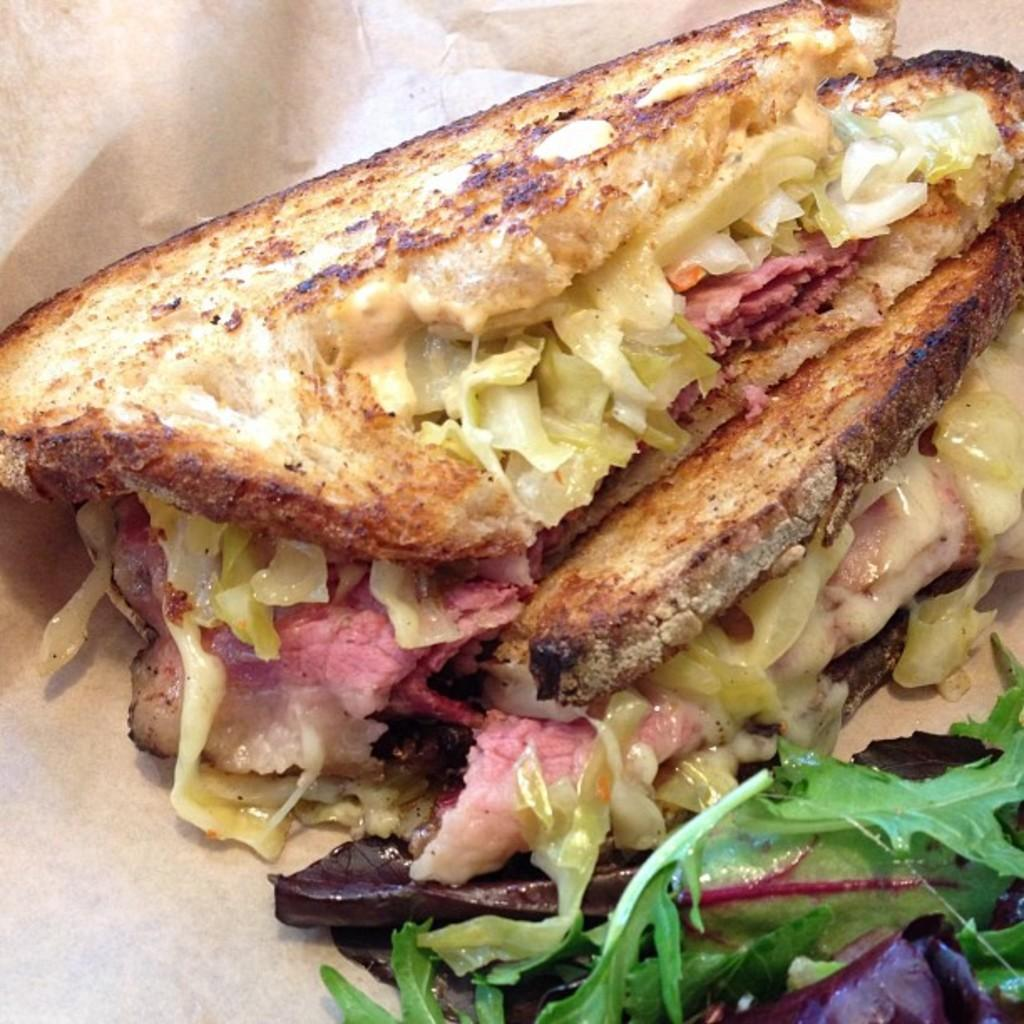What is present in the image? There is there food in the image? On what object is the food placed? The food is on an object, but the specific object is not mentioned in the facts. What color is the background of the image? The background of the image is white in color. How does the book contribute to the pollution in the image? There is no book present in the image, so it cannot contribute to any pollution. 